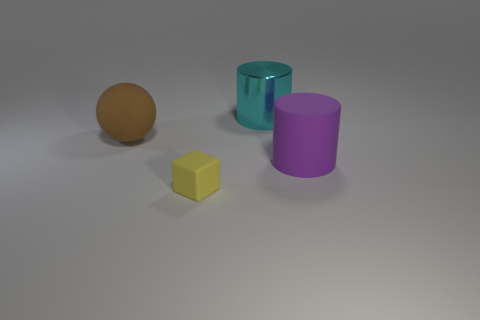Is there anything else that has the same shape as the large brown rubber thing?
Make the answer very short. No. Are there more big metallic objects that are behind the big brown thing than large brown things that are to the right of the large purple matte cylinder?
Offer a very short reply. Yes. Is there a cyan metal object that has the same shape as the big purple thing?
Provide a succinct answer. Yes. How big is the thing that is in front of the large cylinder in front of the large brown matte sphere?
Make the answer very short. Small. The big cyan thing that is behind the large rubber sphere behind the big matte object right of the big cyan object is what shape?
Offer a very short reply. Cylinder. What is the size of the brown object that is made of the same material as the purple cylinder?
Your answer should be very brief. Large. Are there more objects than purple rubber cylinders?
Offer a very short reply. Yes. There is a cyan object that is the same size as the purple rubber thing; what is its material?
Offer a terse response. Metal. Does the cylinder behind the purple cylinder have the same size as the large brown ball?
Give a very brief answer. Yes. What number of cubes are either metal objects or large brown rubber things?
Your response must be concise. 0. 